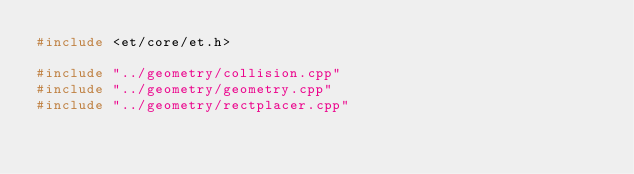<code> <loc_0><loc_0><loc_500><loc_500><_C++_>#include <et/core/et.h>

#include "../geometry/collision.cpp"
#include "../geometry/geometry.cpp"
#include "../geometry/rectplacer.cpp"
</code> 